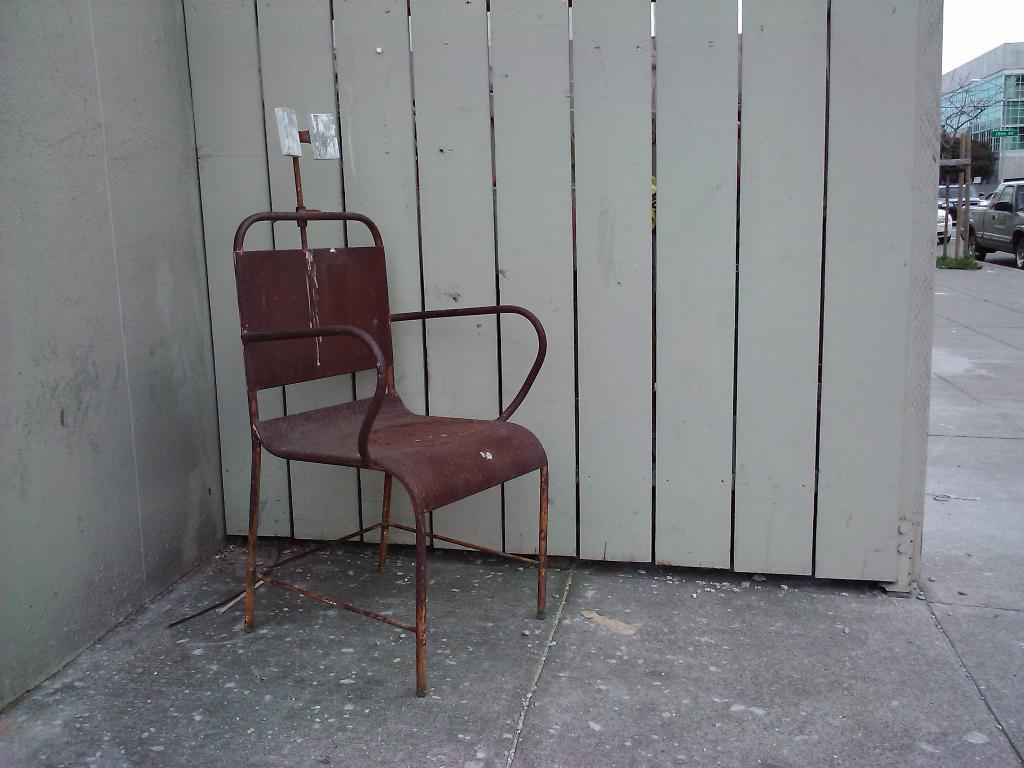What type of furniture is present in the image? There is a chair in the image. What type of barrier can be seen in the image? There is a wooden fence in the image. What type of transportation is visible in the image? There are vehicles visible in the image. What type of structure is on the right side of the image? There is a building on the right side of the image. Where is the playground located in the image? There is no playground present in the image. How many wings can be seen on the chair in the image? The chair in the image does not have wings; it is a standard chair without any additional features. 